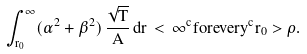<formula> <loc_0><loc_0><loc_500><loc_500>\int _ { r _ { 0 } } ^ { \infty } ( \alpha ^ { 2 } + \beta ^ { 2 } ) \, \frac { \sqrt { T } } { A } \, d r \, < \, \infty ^ { c } { f o r e v e r y } ^ { c } r _ { 0 } > \rho .</formula> 